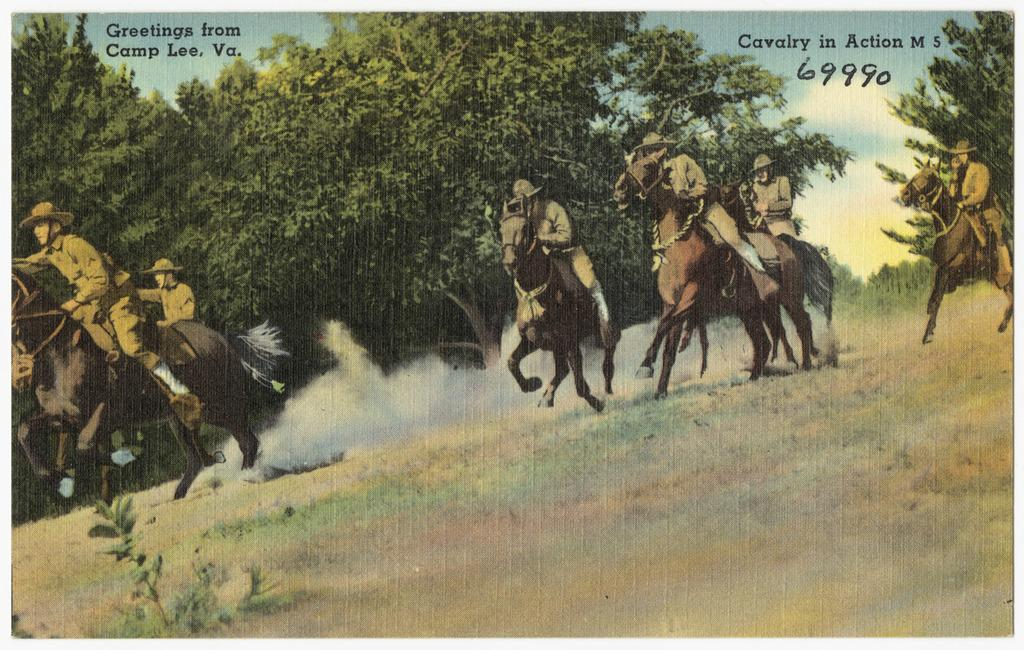What is featured in the image? There is a poster in the image. What is happening in the scene depicted on the poster? The poster depicts people riding horses. What type of environment is shown in the poster? There is greenery visible in the poster, suggesting a natural setting. What else can be seen in the sky in the poster? The sky is visible in the poster. Are there any words or letters on the poster? Yes, there is text on the poster. What type of rake is being used by the people riding horses in the image? There is no rake present in the image; it features of the scene include people riding horses, greenery, and text on the poster. 